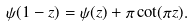Convert formula to latex. <formula><loc_0><loc_0><loc_500><loc_500>\psi ( 1 - z ) = \psi ( z ) + \pi \cot ( \pi z ) .</formula> 